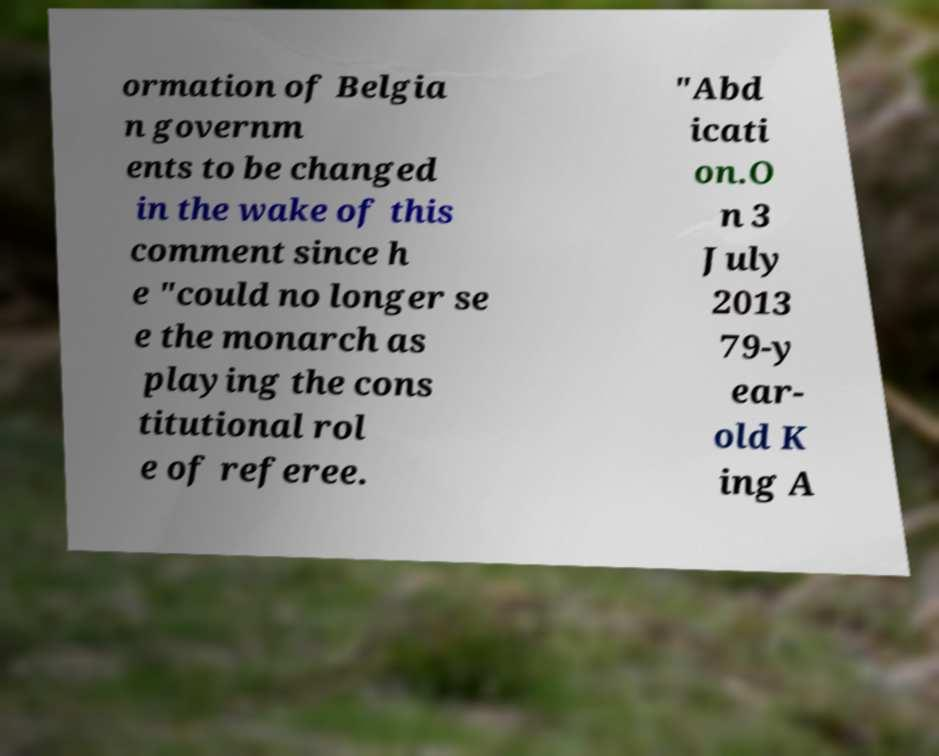Please read and relay the text visible in this image. What does it say? ormation of Belgia n governm ents to be changed in the wake of this comment since h e "could no longer se e the monarch as playing the cons titutional rol e of referee. "Abd icati on.O n 3 July 2013 79-y ear- old K ing A 